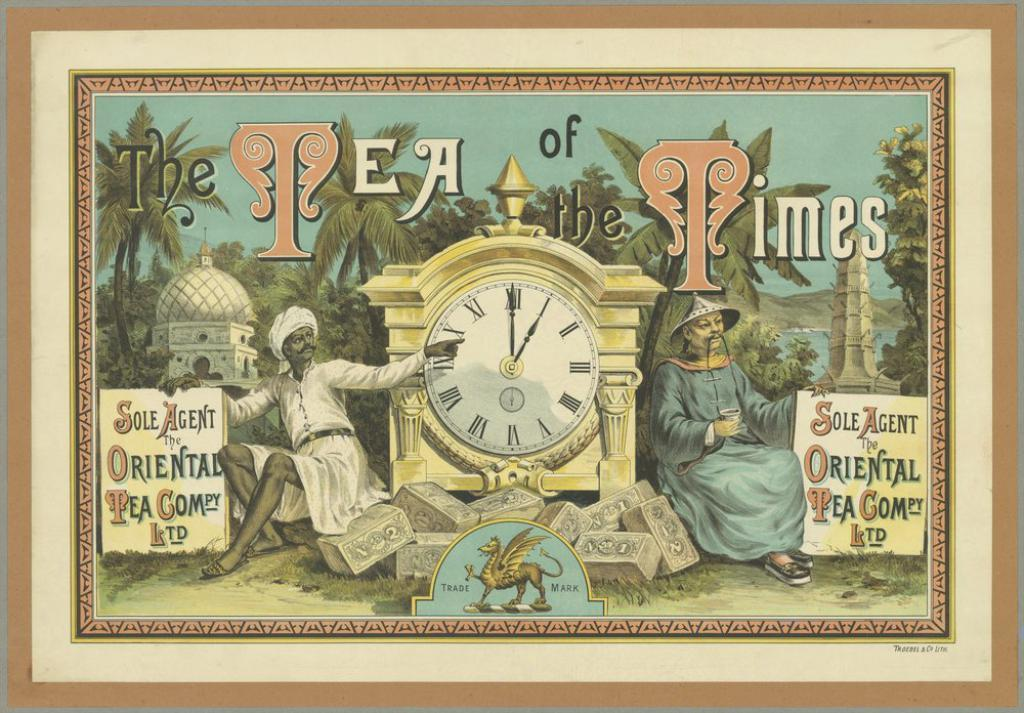Provide a one-sentence caption for the provided image. a picture of two men sitting next to a clock entitled a tea of the times. 